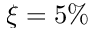<formula> <loc_0><loc_0><loc_500><loc_500>\xi = 5 \%</formula> 